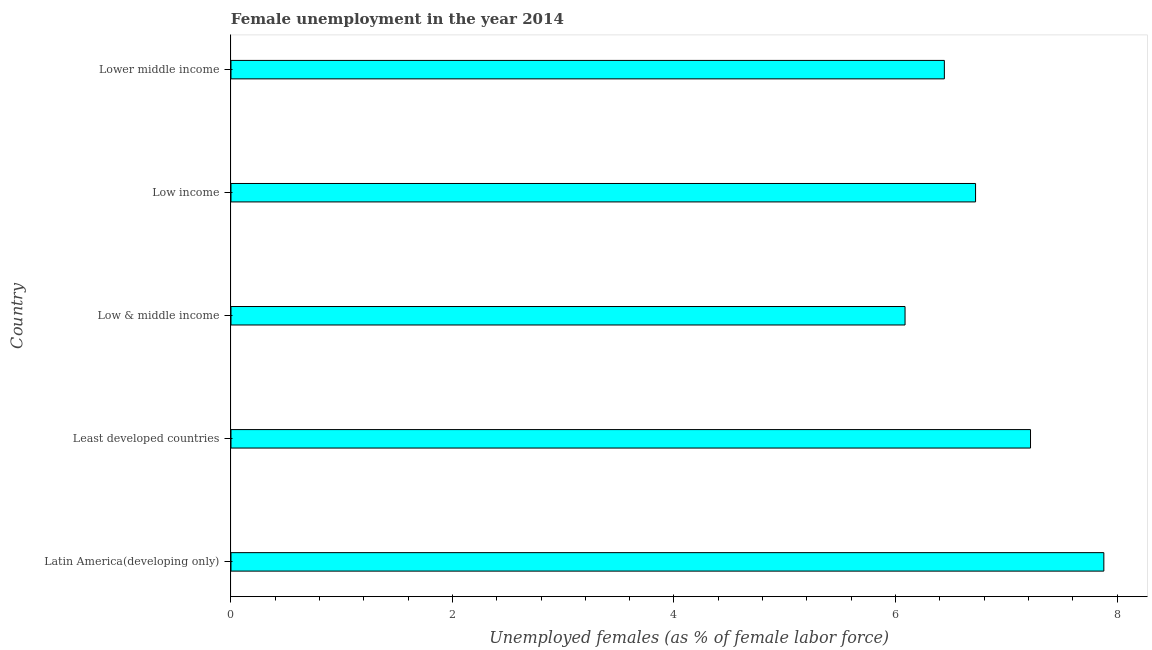Does the graph contain grids?
Ensure brevity in your answer.  No. What is the title of the graph?
Make the answer very short. Female unemployment in the year 2014. What is the label or title of the X-axis?
Your answer should be compact. Unemployed females (as % of female labor force). What is the unemployed females population in Least developed countries?
Provide a short and direct response. 7.22. Across all countries, what is the maximum unemployed females population?
Provide a short and direct response. 7.88. Across all countries, what is the minimum unemployed females population?
Provide a short and direct response. 6.09. In which country was the unemployed females population maximum?
Provide a short and direct response. Latin America(developing only). In which country was the unemployed females population minimum?
Offer a terse response. Low & middle income. What is the sum of the unemployed females population?
Ensure brevity in your answer.  34.35. What is the difference between the unemployed females population in Low & middle income and Low income?
Offer a very short reply. -0.64. What is the average unemployed females population per country?
Your response must be concise. 6.87. What is the median unemployed females population?
Offer a terse response. 6.72. What is the ratio of the unemployed females population in Latin America(developing only) to that in Least developed countries?
Make the answer very short. 1.09. Is the unemployed females population in Latin America(developing only) less than that in Low income?
Make the answer very short. No. What is the difference between the highest and the second highest unemployed females population?
Provide a short and direct response. 0.66. Is the sum of the unemployed females population in Latin America(developing only) and Low income greater than the maximum unemployed females population across all countries?
Offer a very short reply. Yes. What is the difference between the highest and the lowest unemployed females population?
Your response must be concise. 1.79. In how many countries, is the unemployed females population greater than the average unemployed females population taken over all countries?
Offer a very short reply. 2. How many countries are there in the graph?
Your answer should be compact. 5. What is the difference between two consecutive major ticks on the X-axis?
Offer a terse response. 2. Are the values on the major ticks of X-axis written in scientific E-notation?
Your answer should be very brief. No. What is the Unemployed females (as % of female labor force) in Latin America(developing only)?
Provide a short and direct response. 7.88. What is the Unemployed females (as % of female labor force) of Least developed countries?
Ensure brevity in your answer.  7.22. What is the Unemployed females (as % of female labor force) in Low & middle income?
Your answer should be very brief. 6.09. What is the Unemployed females (as % of female labor force) in Low income?
Provide a short and direct response. 6.72. What is the Unemployed females (as % of female labor force) of Lower middle income?
Make the answer very short. 6.44. What is the difference between the Unemployed females (as % of female labor force) in Latin America(developing only) and Least developed countries?
Provide a short and direct response. 0.66. What is the difference between the Unemployed females (as % of female labor force) in Latin America(developing only) and Low & middle income?
Offer a terse response. 1.79. What is the difference between the Unemployed females (as % of female labor force) in Latin America(developing only) and Low income?
Offer a very short reply. 1.16. What is the difference between the Unemployed females (as % of female labor force) in Latin America(developing only) and Lower middle income?
Give a very brief answer. 1.44. What is the difference between the Unemployed females (as % of female labor force) in Least developed countries and Low & middle income?
Provide a short and direct response. 1.13. What is the difference between the Unemployed females (as % of female labor force) in Least developed countries and Low income?
Make the answer very short. 0.5. What is the difference between the Unemployed females (as % of female labor force) in Least developed countries and Lower middle income?
Ensure brevity in your answer.  0.78. What is the difference between the Unemployed females (as % of female labor force) in Low & middle income and Low income?
Offer a very short reply. -0.64. What is the difference between the Unemployed females (as % of female labor force) in Low & middle income and Lower middle income?
Make the answer very short. -0.35. What is the difference between the Unemployed females (as % of female labor force) in Low income and Lower middle income?
Your answer should be very brief. 0.28. What is the ratio of the Unemployed females (as % of female labor force) in Latin America(developing only) to that in Least developed countries?
Your response must be concise. 1.09. What is the ratio of the Unemployed females (as % of female labor force) in Latin America(developing only) to that in Low & middle income?
Your answer should be very brief. 1.29. What is the ratio of the Unemployed females (as % of female labor force) in Latin America(developing only) to that in Low income?
Keep it short and to the point. 1.17. What is the ratio of the Unemployed females (as % of female labor force) in Latin America(developing only) to that in Lower middle income?
Provide a short and direct response. 1.22. What is the ratio of the Unemployed females (as % of female labor force) in Least developed countries to that in Low & middle income?
Offer a very short reply. 1.19. What is the ratio of the Unemployed females (as % of female labor force) in Least developed countries to that in Low income?
Offer a terse response. 1.07. What is the ratio of the Unemployed females (as % of female labor force) in Least developed countries to that in Lower middle income?
Provide a short and direct response. 1.12. What is the ratio of the Unemployed females (as % of female labor force) in Low & middle income to that in Low income?
Your answer should be very brief. 0.91. What is the ratio of the Unemployed females (as % of female labor force) in Low & middle income to that in Lower middle income?
Offer a terse response. 0.94. What is the ratio of the Unemployed females (as % of female labor force) in Low income to that in Lower middle income?
Provide a succinct answer. 1.04. 